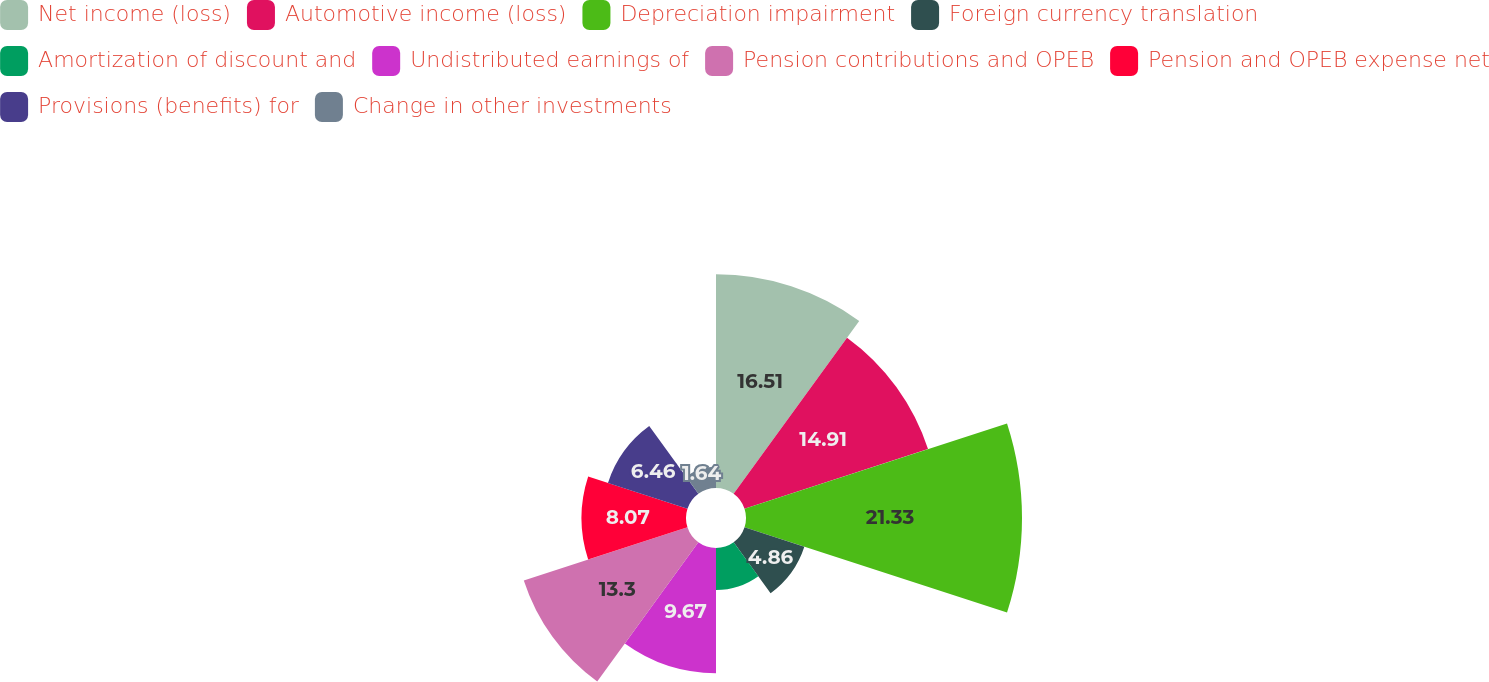<chart> <loc_0><loc_0><loc_500><loc_500><pie_chart><fcel>Net income (loss)<fcel>Automotive income (loss)<fcel>Depreciation impairment<fcel>Foreign currency translation<fcel>Amortization of discount and<fcel>Undistributed earnings of<fcel>Pension contributions and OPEB<fcel>Pension and OPEB expense net<fcel>Provisions (benefits) for<fcel>Change in other investments<nl><fcel>16.51%<fcel>14.91%<fcel>21.33%<fcel>4.86%<fcel>3.25%<fcel>9.67%<fcel>13.3%<fcel>8.07%<fcel>6.46%<fcel>1.64%<nl></chart> 